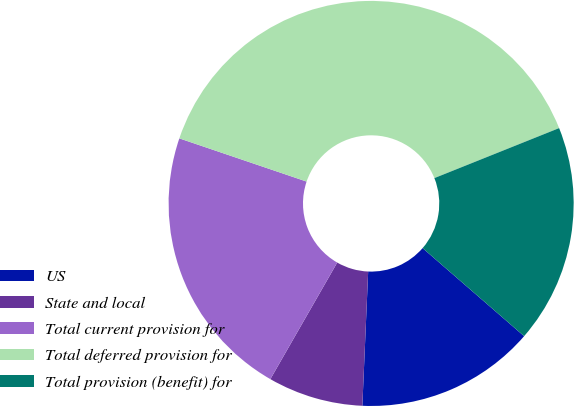<chart> <loc_0><loc_0><loc_500><loc_500><pie_chart><fcel>US<fcel>State and local<fcel>Total current provision for<fcel>Total deferred provision for<fcel>Total provision (benefit) for<nl><fcel>14.32%<fcel>7.6%<fcel>21.92%<fcel>38.73%<fcel>17.44%<nl></chart> 